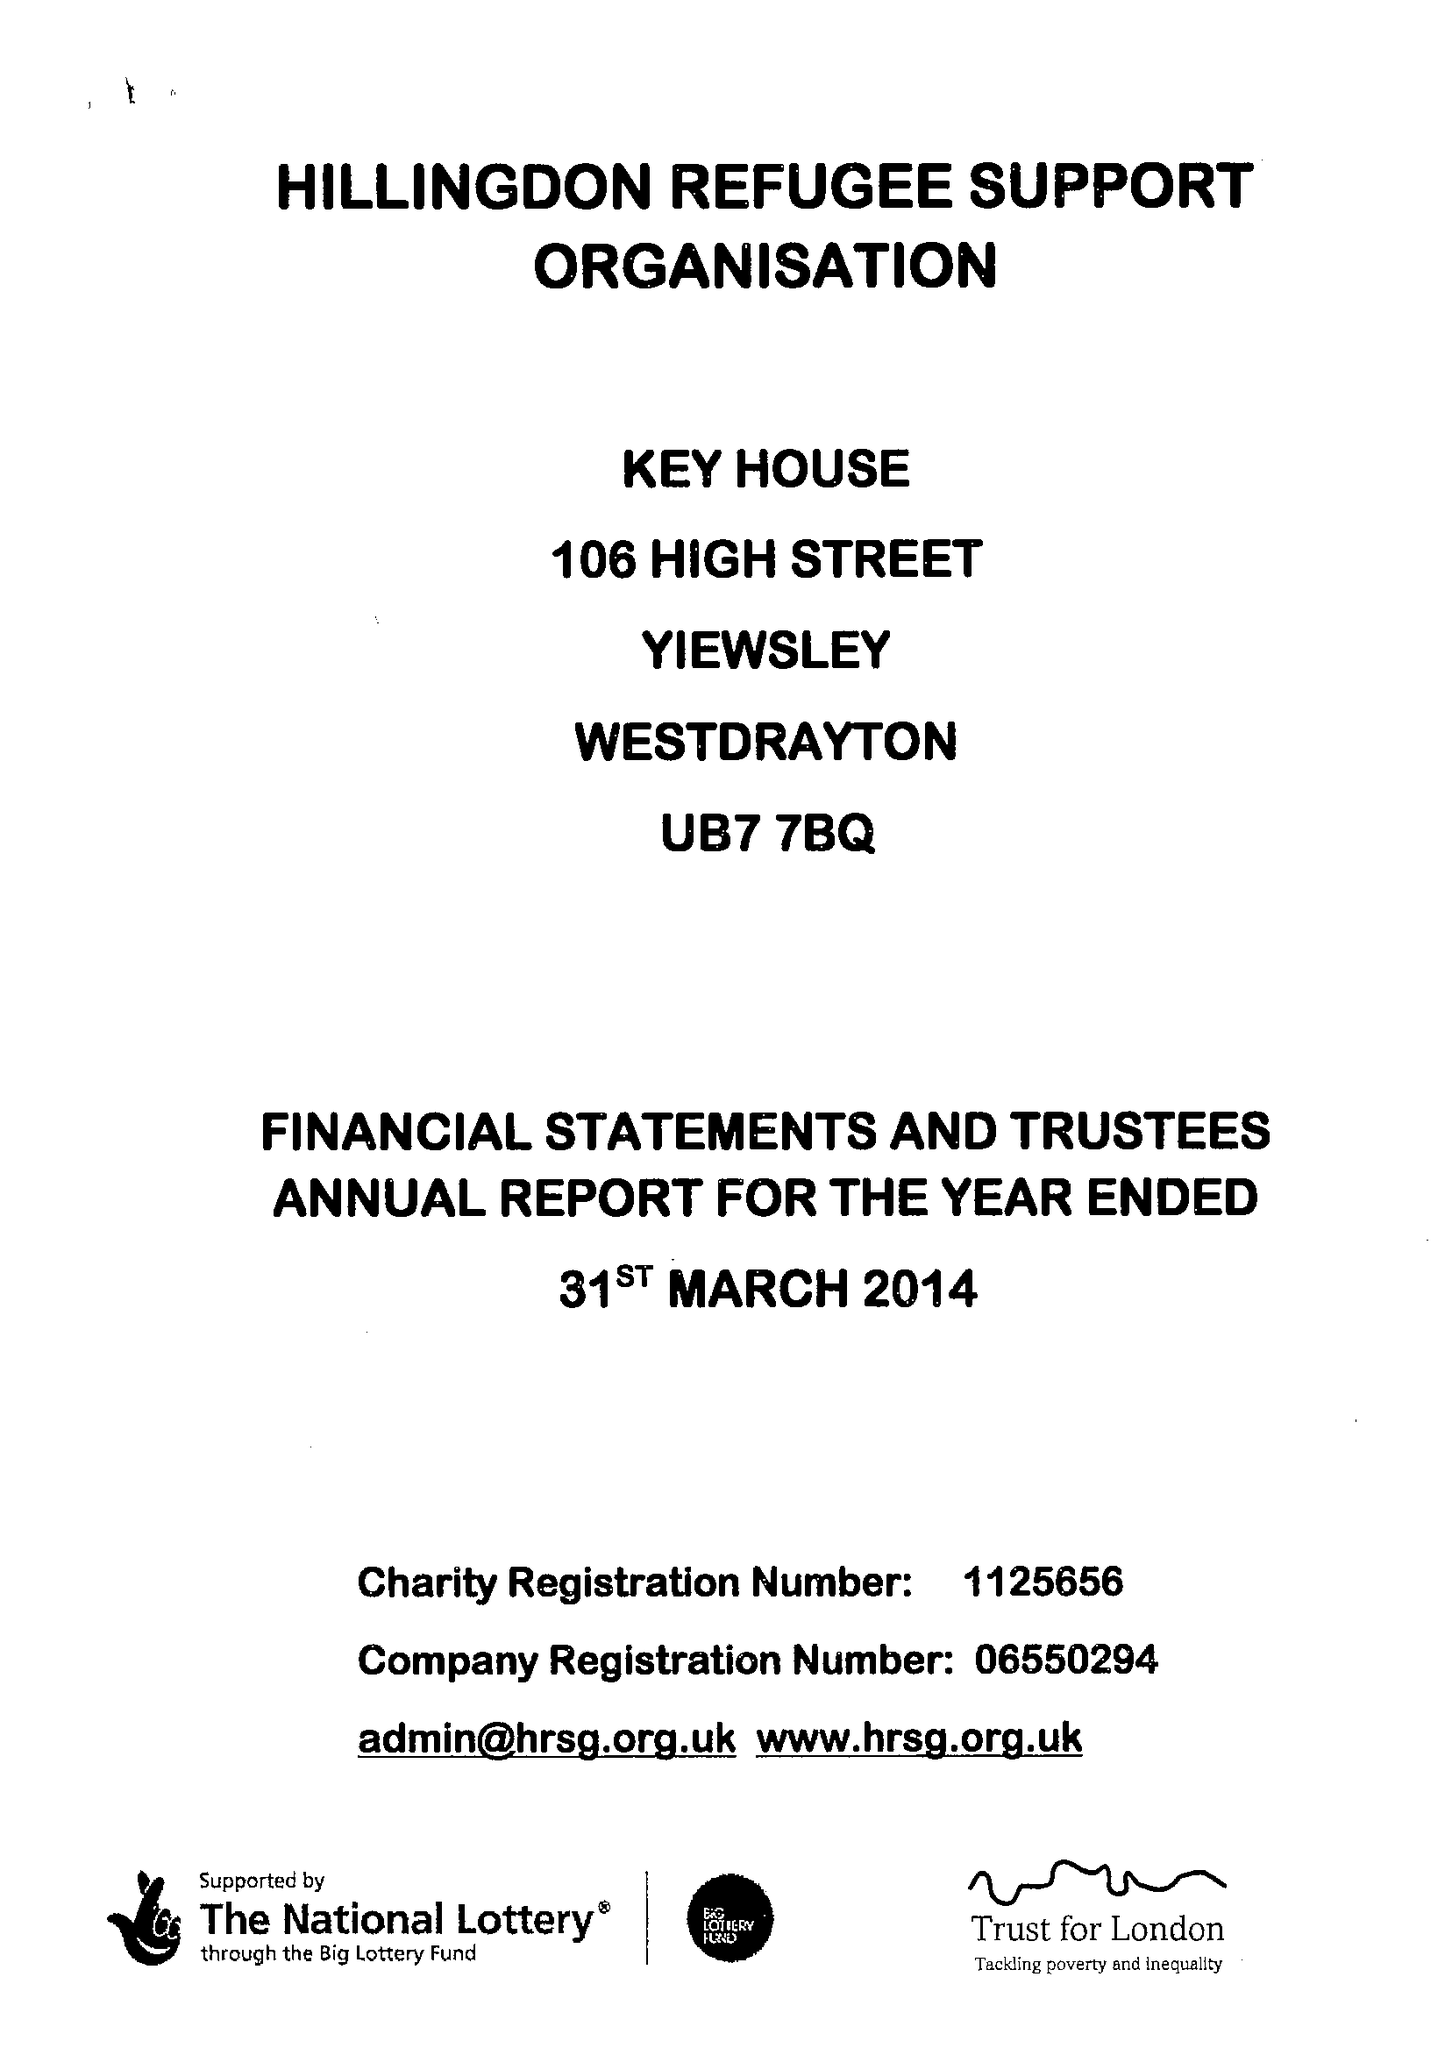What is the value for the charity_name?
Answer the question using a single word or phrase. Hillingdon Refugee Support Organisation 